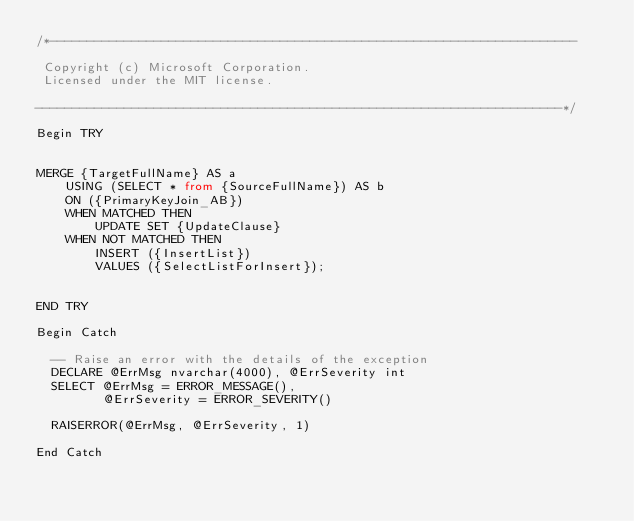Convert code to text. <code><loc_0><loc_0><loc_500><loc_500><_SQL_>/*-----------------------------------------------------------------------

 Copyright (c) Microsoft Corporation.
 Licensed under the MIT license.

-----------------------------------------------------------------------*/
 
Begin TRY


MERGE {TargetFullName} AS a  
    USING (SELECT * from {SourceFullName}) AS b   
    ON ({PrimaryKeyJoin_AB})  
    WHEN MATCHED THEN
        UPDATE SET {UpdateClause}  
    WHEN NOT MATCHED THEN  
        INSERT ({InsertList})  
        VALUES ({SelectListForInsert});  
    

END TRY
 
Begin Catch

  -- Raise an error with the details of the exception
  DECLARE @ErrMsg nvarchar(4000), @ErrSeverity int
  SELECT @ErrMsg = ERROR_MESSAGE(),
         @ErrSeverity = ERROR_SEVERITY()
 
  RAISERROR(@ErrMsg, @ErrSeverity, 1)
 
End Catch
</code> 